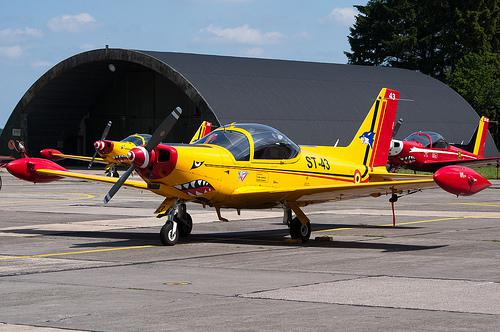Question: why for one reason do people ride in airplanes?
Choices:
A. War.
B. Recreation.
C. Skydiving.
D. Transportation.
Answer with the letter. Answer: D Question: how are most airplanes fueled?
Choices:
A. Jet fuel.
B. Solar power.
C. Wind.
D. Gasoline.
Answer with the letter. Answer: D Question: what type of vehicle is this?
Choices:
A. Boat.
B. Bus.
C. Airplane.
D. Helicopter.
Answer with the letter. Answer: C Question: where was this photo probably taken?
Choices:
A. Baseball field.
B. Beach.
C. Football stadium.
D. Airfield.
Answer with the letter. Answer: D 